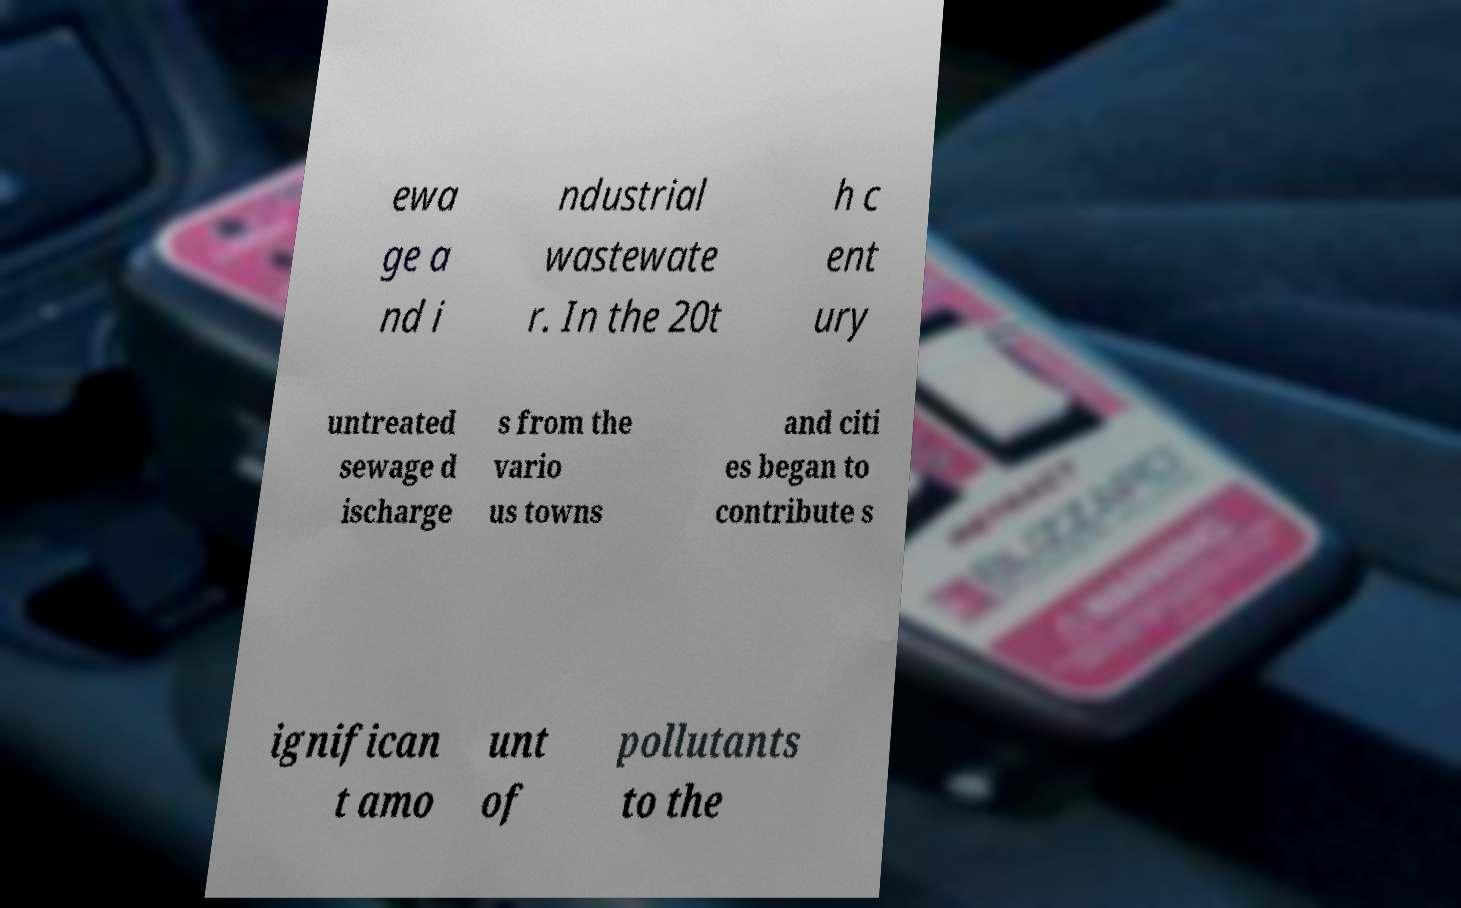Please read and relay the text visible in this image. What does it say? ewa ge a nd i ndustrial wastewate r. In the 20t h c ent ury untreated sewage d ischarge s from the vario us towns and citi es began to contribute s ignifican t amo unt of pollutants to the 